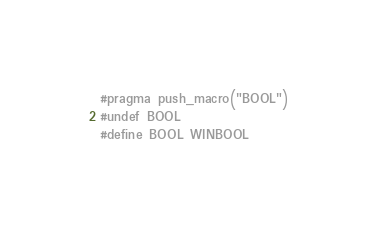Convert code to text. <code><loc_0><loc_0><loc_500><loc_500><_C_>#pragma push_macro("BOOL")
#undef BOOL
#define BOOL WINBOOL

</code> 